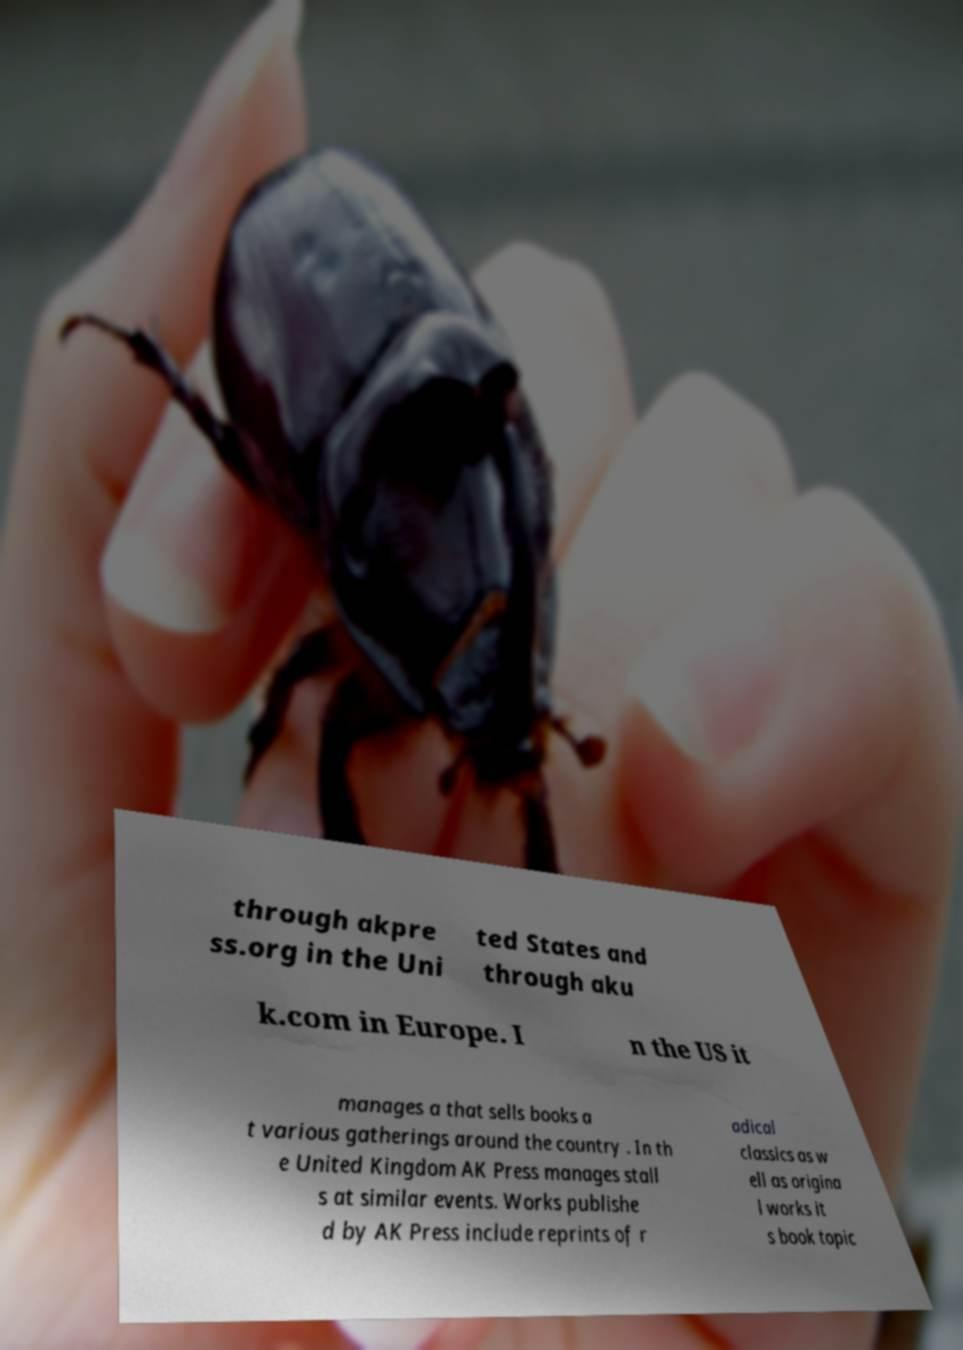Can you accurately transcribe the text from the provided image for me? through akpre ss.org in the Uni ted States and through aku k.com in Europe. I n the US it manages a that sells books a t various gatherings around the country . In th e United Kingdom AK Press manages stall s at similar events. Works publishe d by AK Press include reprints of r adical classics as w ell as origina l works it s book topic 